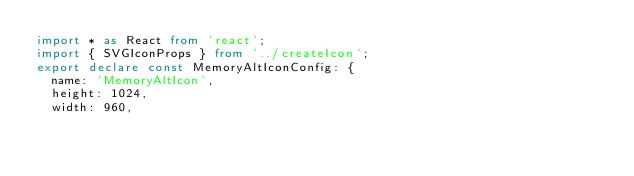Convert code to text. <code><loc_0><loc_0><loc_500><loc_500><_TypeScript_>import * as React from 'react';
import { SVGIconProps } from '../createIcon';
export declare const MemoryAltIconConfig: {
  name: 'MemoryAltIcon',
  height: 1024,
  width: 960,</code> 